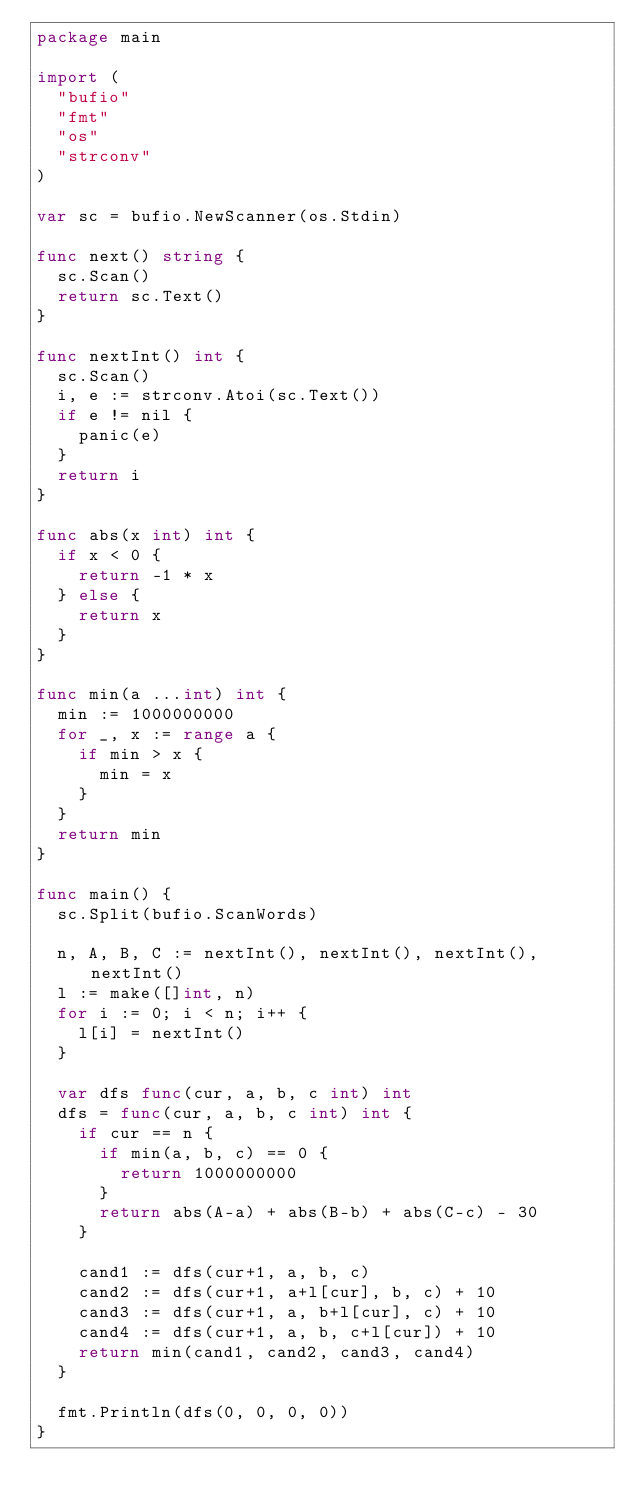<code> <loc_0><loc_0><loc_500><loc_500><_Go_>package main

import (
	"bufio"
	"fmt"
	"os"
	"strconv"
)

var sc = bufio.NewScanner(os.Stdin)

func next() string {
	sc.Scan()
	return sc.Text()
}

func nextInt() int {
	sc.Scan()
	i, e := strconv.Atoi(sc.Text())
	if e != nil {
		panic(e)
	}
	return i
}

func abs(x int) int {
	if x < 0 {
		return -1 * x
	} else {
		return x
	}
}

func min(a ...int) int {
	min := 1000000000
	for _, x := range a {
		if min > x {
			min = x
		}
	}
	return min
}

func main() {
	sc.Split(bufio.ScanWords)

	n, A, B, C := nextInt(), nextInt(), nextInt(), nextInt()
	l := make([]int, n)
	for i := 0; i < n; i++ {
		l[i] = nextInt()
	}

	var dfs func(cur, a, b, c int) int
	dfs = func(cur, a, b, c int) int {
		if cur == n {
			if min(a, b, c) == 0 {
				return 1000000000
			}
			return abs(A-a) + abs(B-b) + abs(C-c) - 30
		}

		cand1 := dfs(cur+1, a, b, c)
		cand2 := dfs(cur+1, a+l[cur], b, c) + 10
		cand3 := dfs(cur+1, a, b+l[cur], c) + 10
		cand4 := dfs(cur+1, a, b, c+l[cur]) + 10
		return min(cand1, cand2, cand3, cand4)
	}

	fmt.Println(dfs(0, 0, 0, 0))
}</code> 